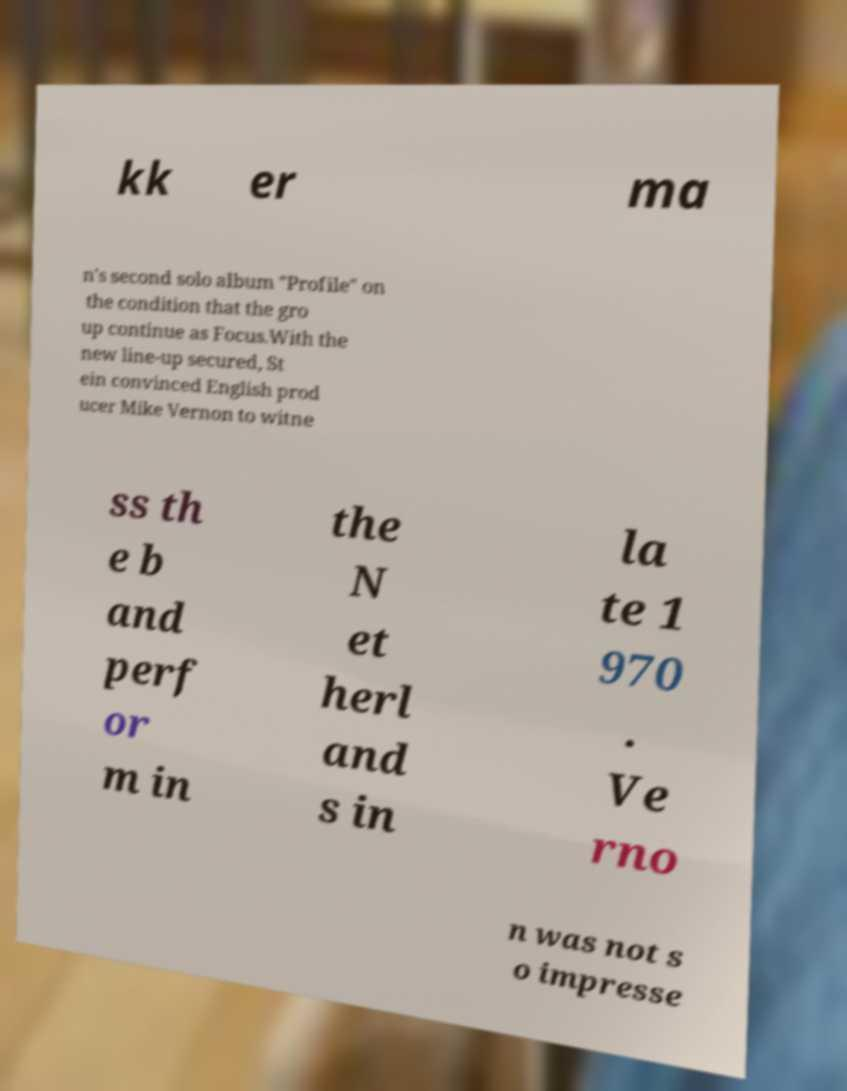Could you assist in decoding the text presented in this image and type it out clearly? kk er ma n's second solo album "Profile" on the condition that the gro up continue as Focus.With the new line-up secured, St ein convinced English prod ucer Mike Vernon to witne ss th e b and perf or m in the N et herl and s in la te 1 970 . Ve rno n was not s o impresse 